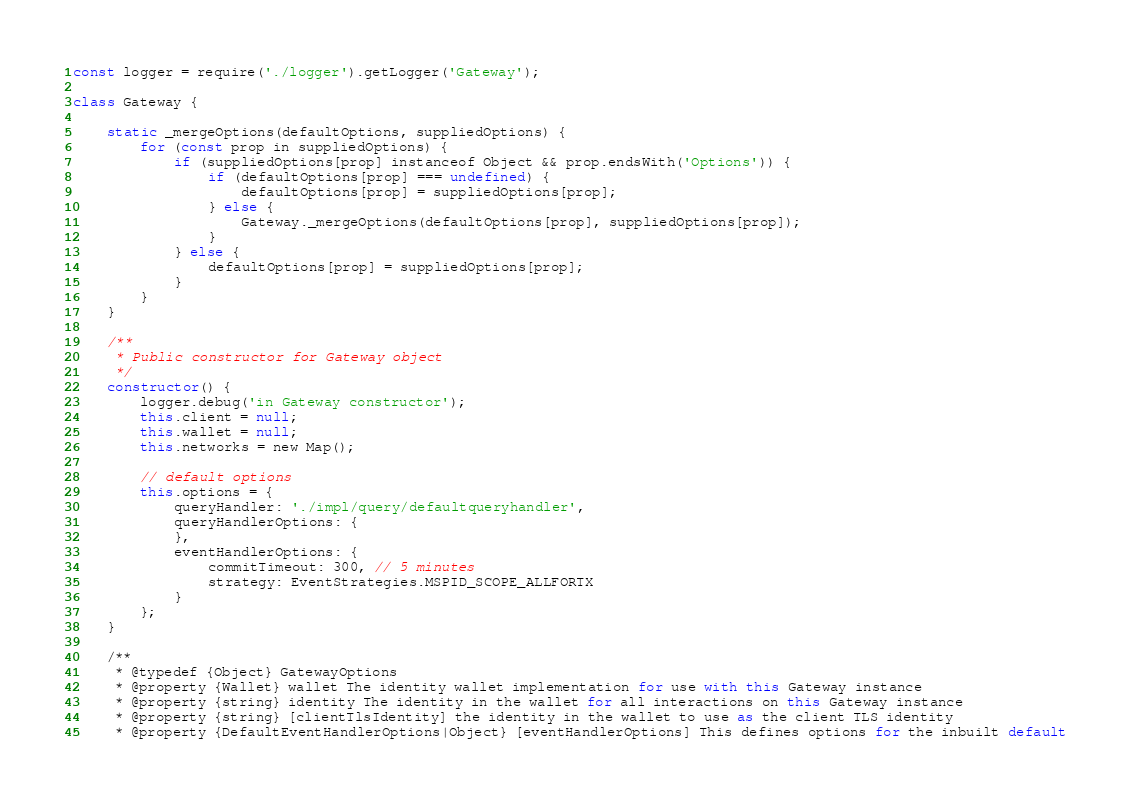Convert code to text. <code><loc_0><loc_0><loc_500><loc_500><_JavaScript_>
const logger = require('./logger').getLogger('Gateway');

class Gateway {

	static _mergeOptions(defaultOptions, suppliedOptions) {
		for (const prop in suppliedOptions) {
			if (suppliedOptions[prop] instanceof Object && prop.endsWith('Options')) {
				if (defaultOptions[prop] === undefined) {
					defaultOptions[prop] = suppliedOptions[prop];
				} else {
					Gateway._mergeOptions(defaultOptions[prop], suppliedOptions[prop]);
				}
			} else {
				defaultOptions[prop] = suppliedOptions[prop];
			}
		}
	}

	/**
	 * Public constructor for Gateway object
	 */
	constructor() {
		logger.debug('in Gateway constructor');
		this.client = null;
		this.wallet = null;
		this.networks = new Map();

		// default options
		this.options = {
			queryHandler: './impl/query/defaultqueryhandler',
			queryHandlerOptions: {
			},
			eventHandlerOptions: {
				commitTimeout: 300, // 5 minutes
				strategy: EventStrategies.MSPID_SCOPE_ALLFORTX
			}
		};
	}

	/**
 	 * @typedef {Object} GatewayOptions
	 * @property {Wallet} wallet The identity wallet implementation for use with this Gateway instance
 	 * @property {string} identity The identity in the wallet for all interactions on this Gateway instance
	 * @property {string} [clientTlsIdentity] the identity in the wallet to use as the client TLS identity
	 * @property {DefaultEventHandlerOptions|Object} [eventHandlerOptions] This defines options for the inbuilt default</code> 